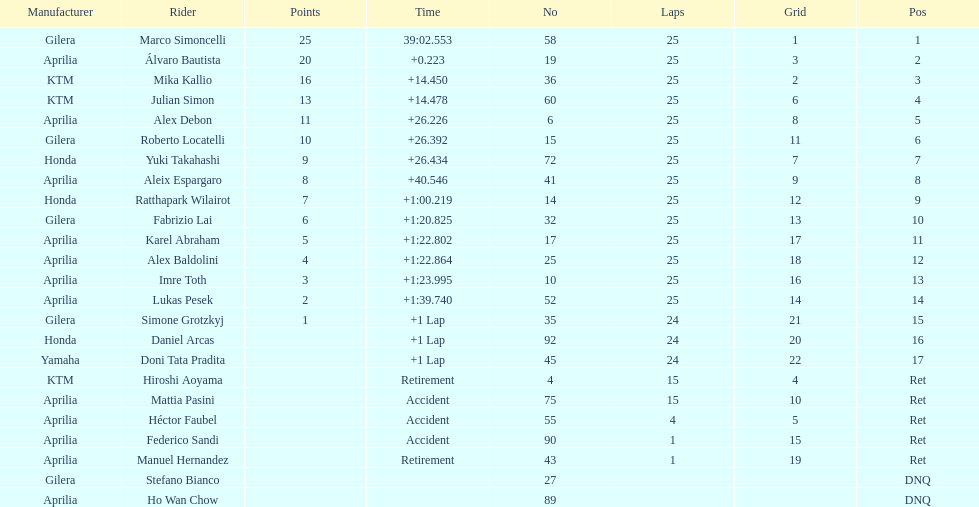Did marco simoncelli or alvaro bautista held rank 1? Marco Simoncelli. 